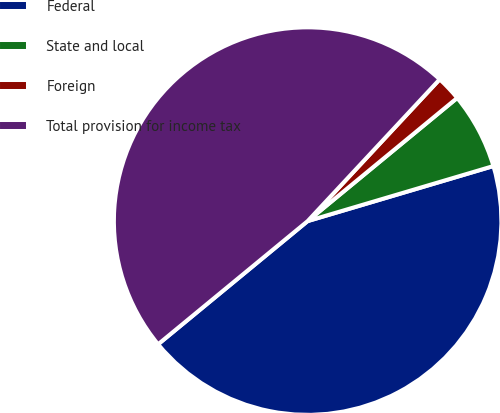Convert chart to OTSL. <chart><loc_0><loc_0><loc_500><loc_500><pie_chart><fcel>Federal<fcel>State and local<fcel>Foreign<fcel>Total provision for income tax<nl><fcel>43.62%<fcel>6.38%<fcel>2.1%<fcel>47.9%<nl></chart> 